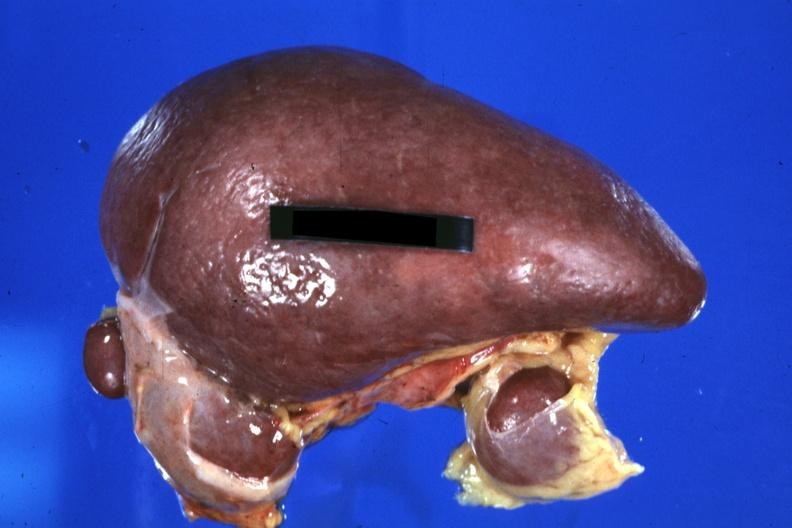s traumatic rupture present?
Answer the question using a single word or phrase. No 